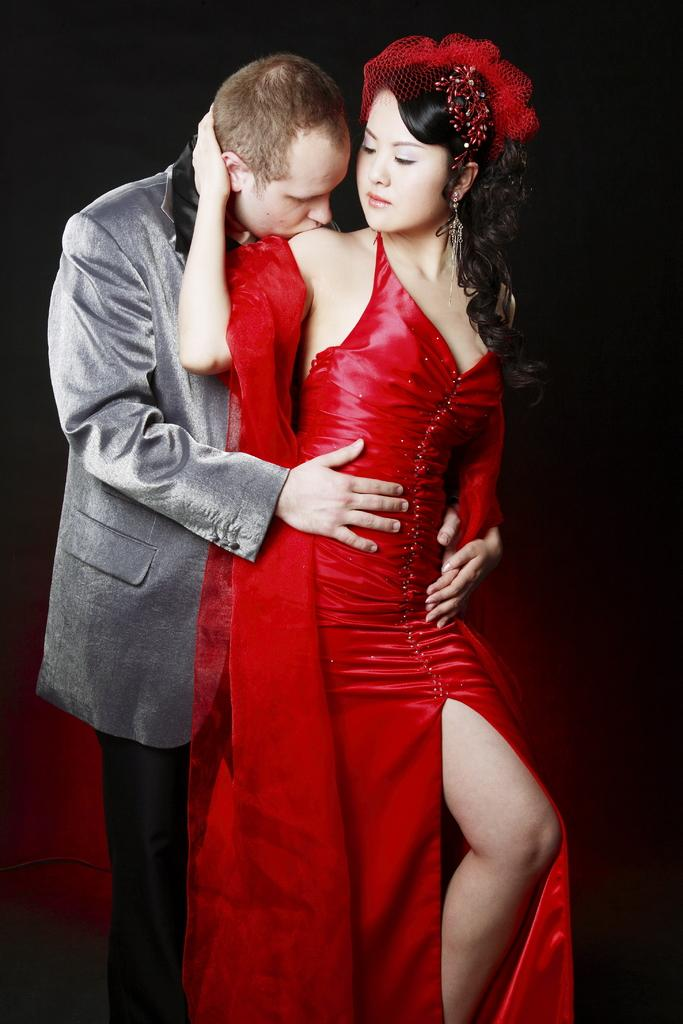What is the man in the image wearing? The man is wearing a suit. What is the woman in the image wearing? The woman is wearing a dress. What is the man doing to the woman in the image? The man is kissing the woman on her shoulder. What can be observed about the lighting in the image? The background of the image is dark. How many buns are on the table in the image? There are no buns present in the image. What type of chairs can be seen in the image? There are no chairs visible in the image. 